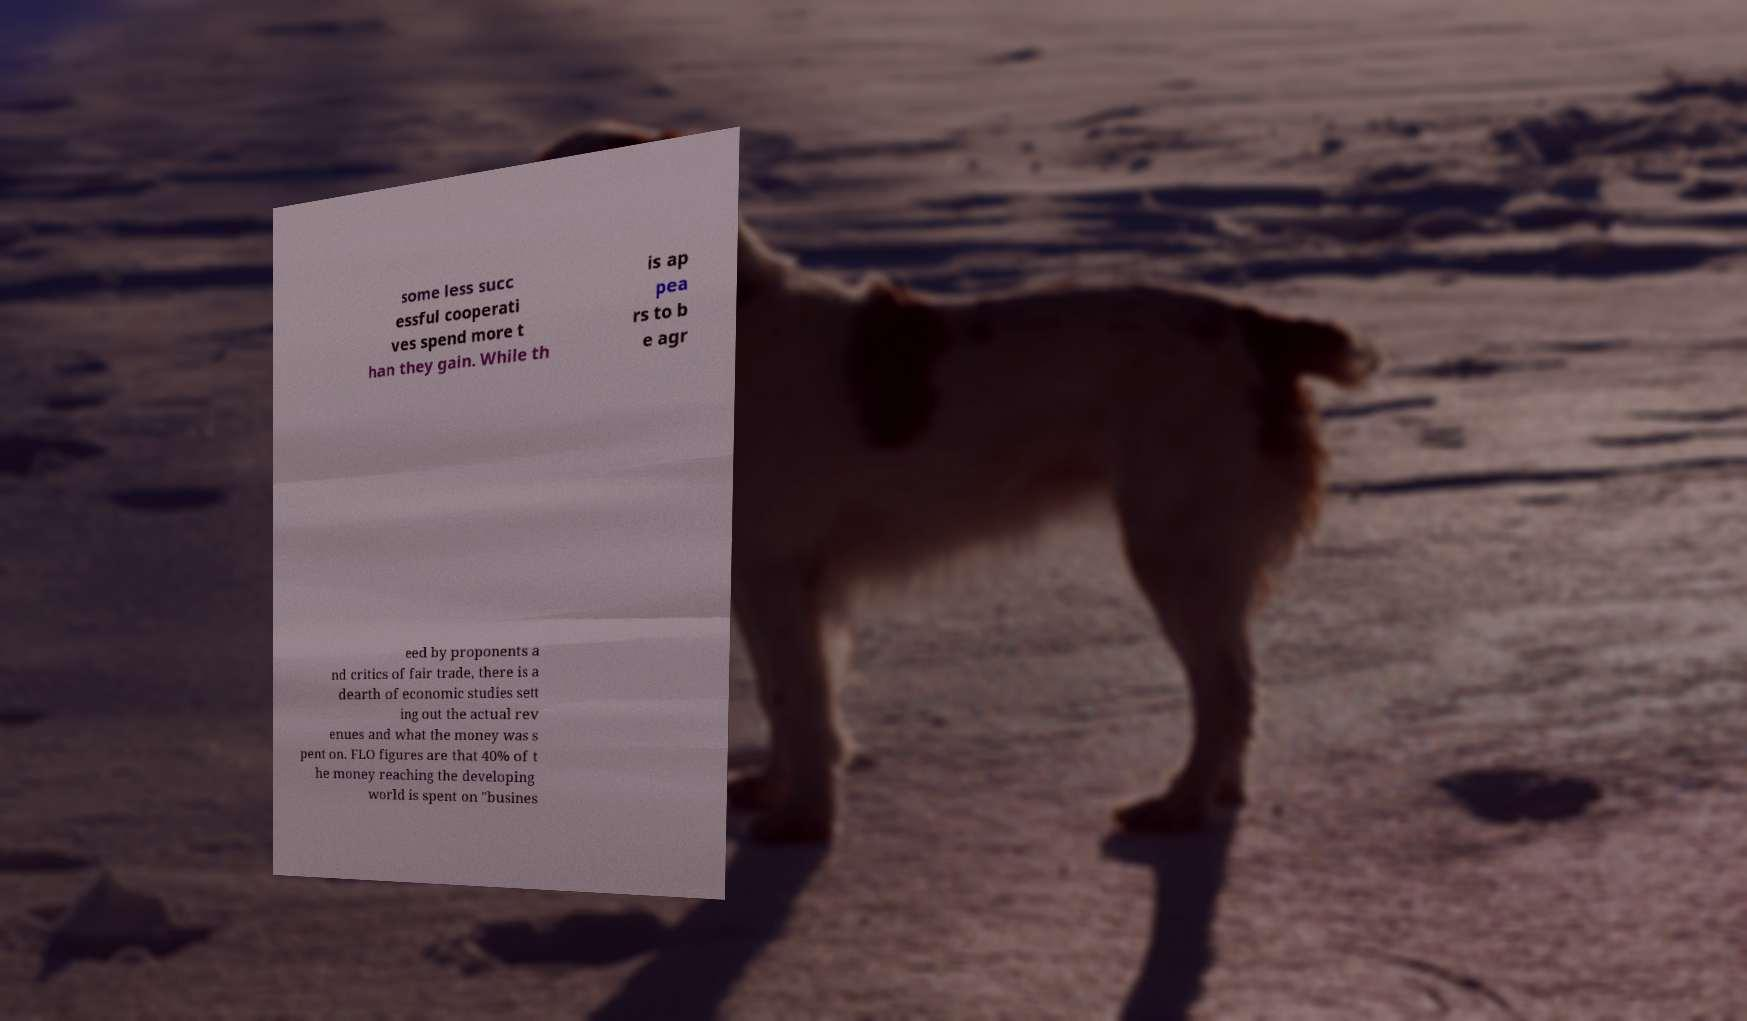Please identify and transcribe the text found in this image. some less succ essful cooperati ves spend more t han they gain. While th is ap pea rs to b e agr eed by proponents a nd critics of fair trade, there is a dearth of economic studies sett ing out the actual rev enues and what the money was s pent on. FLO figures are that 40% of t he money reaching the developing world is spent on "busines 